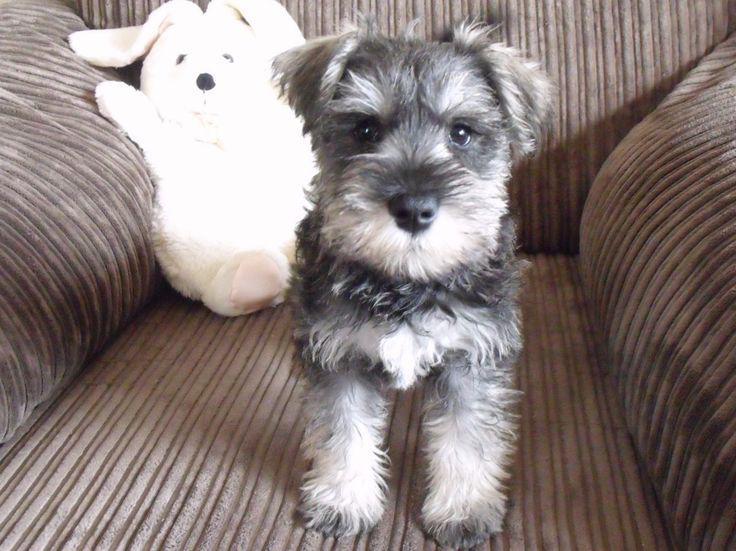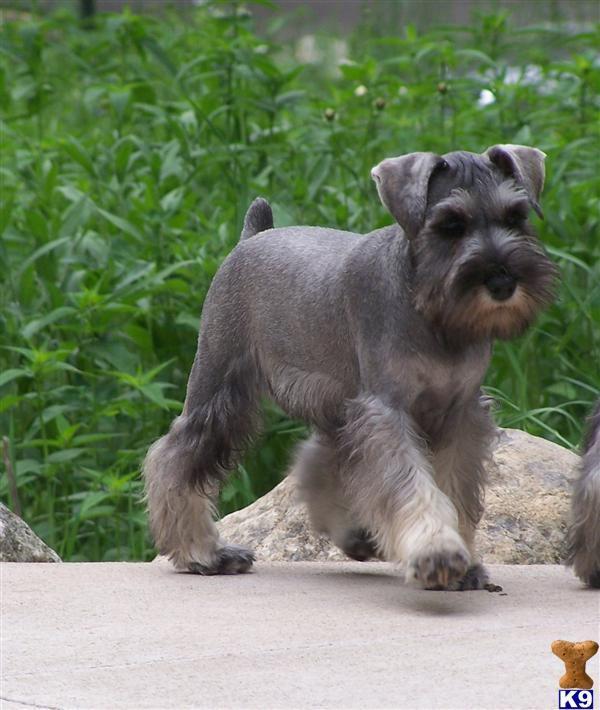The first image is the image on the left, the second image is the image on the right. Assess this claim about the two images: "The dog in the image on the left is indoors". Correct or not? Answer yes or no. Yes. The first image is the image on the left, the second image is the image on the right. For the images shown, is this caption "There is a dog walking on the pavement in the right image." true? Answer yes or no. Yes. 